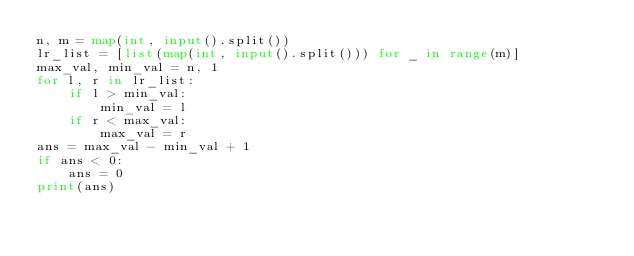<code> <loc_0><loc_0><loc_500><loc_500><_Python_>n, m = map(int, input().split())
lr_list = [list(map(int, input().split())) for _ in range(m)]
max_val, min_val = n, 1
for l, r in lr_list:
    if l > min_val:
        min_val = l
    if r < max_val:
        max_val = r
ans = max_val - min_val + 1
if ans < 0:
    ans = 0
print(ans)
</code> 